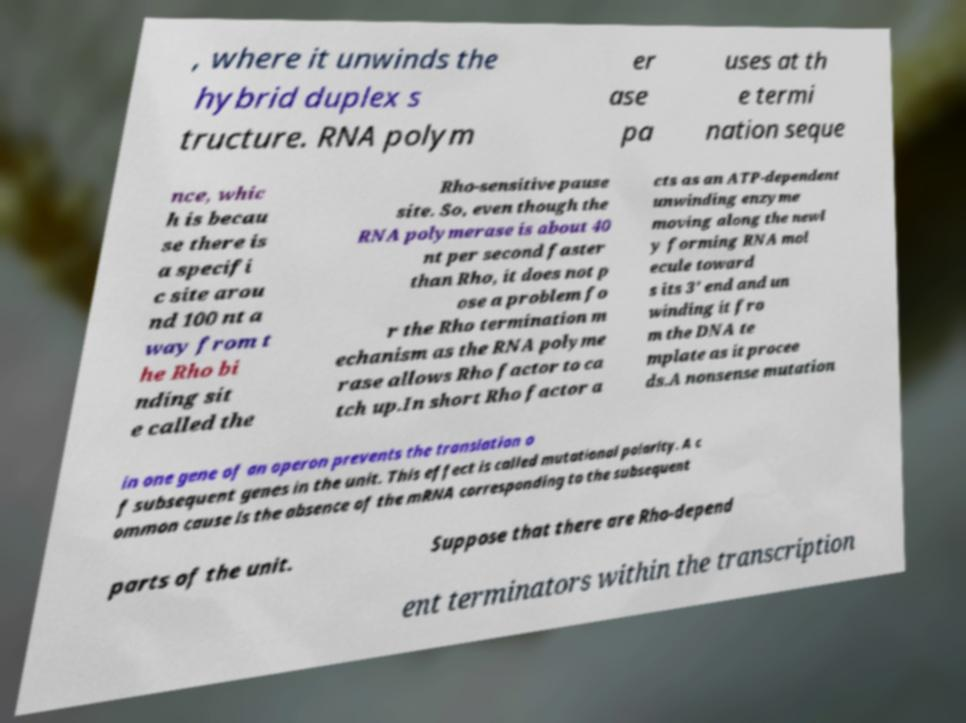For documentation purposes, I need the text within this image transcribed. Could you provide that? , where it unwinds the hybrid duplex s tructure. RNA polym er ase pa uses at th e termi nation seque nce, whic h is becau se there is a specifi c site arou nd 100 nt a way from t he Rho bi nding sit e called the Rho-sensitive pause site. So, even though the RNA polymerase is about 40 nt per second faster than Rho, it does not p ose a problem fo r the Rho termination m echanism as the RNA polyme rase allows Rho factor to ca tch up.In short Rho factor a cts as an ATP-dependent unwinding enzyme moving along the newl y forming RNA mol ecule toward s its 3′ end and un winding it fro m the DNA te mplate as it procee ds.A nonsense mutation in one gene of an operon prevents the translation o f subsequent genes in the unit. This effect is called mutational polarity. A c ommon cause is the absence of the mRNA corresponding to the subsequent parts of the unit. Suppose that there are Rho-depend ent terminators within the transcription 